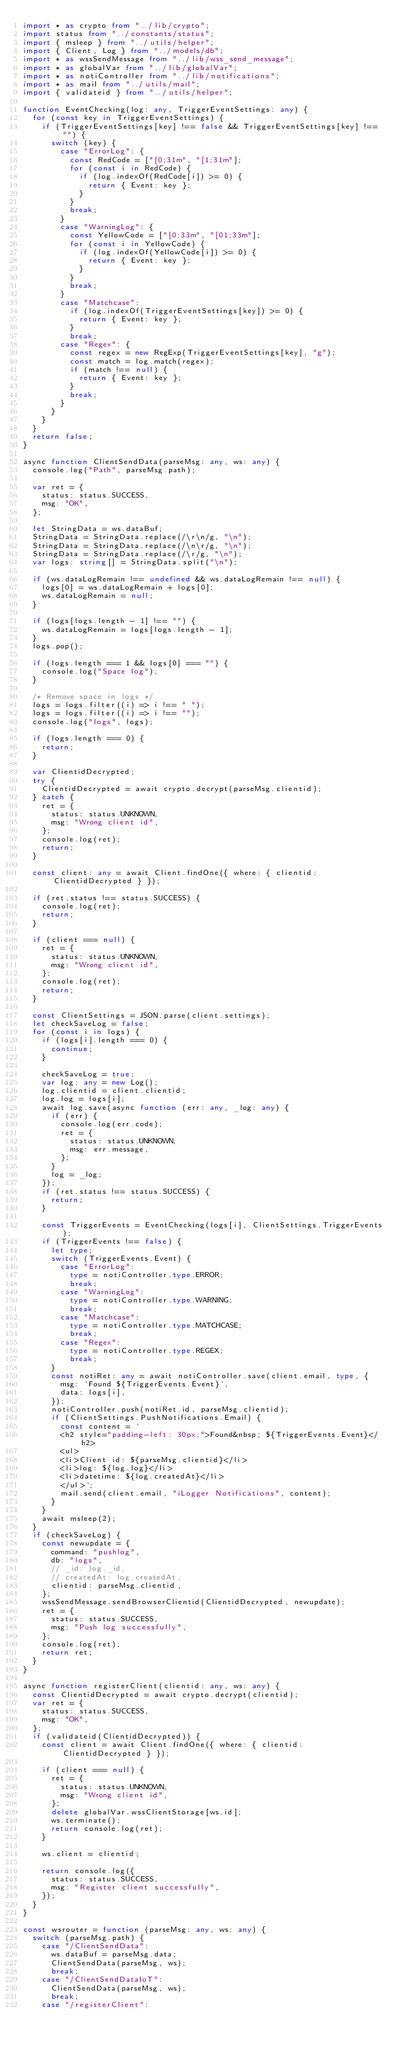<code> <loc_0><loc_0><loc_500><loc_500><_TypeScript_>import * as crypto from "../lib/crypto";
import status from "../constants/status";
import { msleep } from "../utils/helper";
import { Client, Log } from "../models/db";
import * as wssSendMessage from "../lib/wss_send_message";
import * as globalVar from "../lib/globalVar";
import * as notiController from "../lib/notifications";
import * as mail from "../utils/mail";
import { validateid } from "../utils/helper";

function EventChecking(log: any, TriggerEventSettings: any) {
  for (const key in TriggerEventSettings) {
    if (TriggerEventSettings[key] !== false && TriggerEventSettings[key] !== "") {
      switch (key) {
        case "ErrorLog": {
          const RedCode = ["[0;31m", "[1;31m"];
          for (const i in RedCode) {
            if (log.indexOf(RedCode[i]) >= 0) {
              return { Event: key };
            }
          }
          break;
        }
        case "WarningLog": {
          const YellowCode = ["[0;33m", "[01;33m"];
          for (const i in YellowCode) {
            if (log.indexOf(YellowCode[i]) >= 0) {
              return { Event: key };
            }
          }
          break;
        }
        case "Matchcase":
          if (log.indexOf(TriggerEventSettings[key]) >= 0) {
            return { Event: key };
          }
          break;
        case "Regex": {
          const regex = new RegExp(TriggerEventSettings[key], "g");
          const match = log.match(regex);
          if (match !== null) {
            return { Event: key };
          }
          break;
        }
      }
    }
  }
  return false;
}

async function ClientSendData(parseMsg: any, ws: any) {
  console.log("Path", parseMsg.path);

  var ret = {
    status: status.SUCCESS,
    msg: "OK",
  };

  let StringData = ws.dataBuf;
  StringData = StringData.replace(/\r\n/g, "\n");
  StringData = StringData.replace(/\n\r/g, "\n");
  StringData = StringData.replace(/\r/g, "\n");
  var logs: string[] = StringData.split("\n");

  if (ws.dataLogRemain !== undefined && ws.dataLogRemain !== null) {
    logs[0] = ws.dataLogRemain + logs[0];
    ws.dataLogRemain = null;
  }

  if (logs[logs.length - 1] !== "") {
    ws.dataLogRemain = logs[logs.length - 1];
  }
  logs.pop();

  if (logs.length === 1 && logs[0] === "") {
    console.log("Space log");
  }

  /* Remove space in logs */
  logs = logs.filter((i) => i !== " ");
  logs = logs.filter((i) => i !== "");
  console.log("logs", logs);

  if (logs.length === 0) {
    return;
  }

  var ClientidDecrypted;
  try {
    ClientidDecrypted = await crypto.decrypt(parseMsg.clientid);
  } catch {
    ret = {
      status: status.UNKNOWN,
      msg: "Wrong client id",
    };
    console.log(ret);
    return;
  }

  const client: any = await Client.findOne({ where: { clientid: ClientidDecrypted } });

  if (ret.status !== status.SUCCESS) {
    console.log(ret);
    return;
  }

  if (client === null) {
    ret = {
      status: status.UNKNOWN,
      msg: "Wrong client id",
    };
    console.log(ret);
    return;
  }

  const ClientSettings = JSON.parse(client.settings);
  let checkSaveLog = false;
  for (const i in logs) {
    if (logs[i].length === 0) {
      continue;
    }

    checkSaveLog = true;
    var log: any = new Log();
    log.clientid = client.clientid;
    log.log = logs[i];
    await log.save(async function (err: any, _log: any) {
      if (err) {
        console.log(err.code);
        ret = {
          status: status.UNKNOWN,
          msg: err.message,
        };
      }
      log = _log;
    });
    if (ret.status !== status.SUCCESS) {
      return;
    }

    const TriggerEvents = EventChecking(logs[i], ClientSettings.TriggerEvents);
    if (TriggerEvents !== false) {
      let type;
      switch (TriggerEvents.Event) {
        case "ErrorLog":
          type = notiController.type.ERROR;
          break;
        case "WarningLog":
          type = notiController.type.WARNING;
          break;
        case "Matchcase":
          type = notiController.type.MATCHCASE;
          break;
        case "Regex":
          type = notiController.type.REGEX;
          break;
      }
      const notiRet: any = await notiController.save(client.email, type, {
        msg: `Found ${TriggerEvents.Event}`,
        data: logs[i],
      });
      notiController.push(notiRet.id, parseMsg.clientid);
      if (ClientSettings.PushNotifications.Email) {
        const content = `
        <h2 style="padding-left: 30px;">Found&nbsp; ${TriggerEvents.Event}</h2>
        <ul>
        <li>Client id: ${parseMsg.clientid}</li>
        <li>log: ${log.log}</li>
        <li>datetime: ${log.createdAt}</li>
        </ul>`;
        mail.send(client.email, "iLogger Notifications", content);
      }
    }
    await msleep(2);
  }
  if (checkSaveLog) {
    const newupdate = {
      command: "pushlog",
      db: "logs",
      // _id: log._id,
      // createdAt: log.createdAt,
      clientid: parseMsg.clientid,
    };
    wssSendMessage.sendBrowserClientid(ClientidDecrypted, newupdate);
    ret = {
      status: status.SUCCESS,
      msg: "Push log successfully",
    };
    console.log(ret);
    return ret;
  }
}

async function registerClient(clientid: any, ws: any) {
  const ClientidDecrypted = await crypto.decrypt(clientid);
  var ret = {
    status: status.SUCCESS,
    msg: "OK",
  };
  if (validateid(ClientidDecrypted)) {
    const client = await Client.findOne({ where: { clientid: ClientidDecrypted } });

    if (client === null) {
      ret = {
        status: status.UNKNOWN,
        msg: "Wrong client id",
      };
      delete globalVar.wssClientStorage[ws.id];
      ws.terminate();
      return console.log(ret);
    }

    ws.client = clientid;

    return console.log({
      status: status.SUCCESS,
      msg: "Register client successfully",
    });
  }
}

const wsrouter = function (parseMsg: any, ws: any) {
  switch (parseMsg.path) {
    case "/ClientSendData":
      ws.dataBuf = parseMsg.data;
      ClientSendData(parseMsg, ws);
      break;
    case "/ClientSendDataIoT":
      ClientSendData(parseMsg, ws);
      break;
    case "/registerClient":</code> 